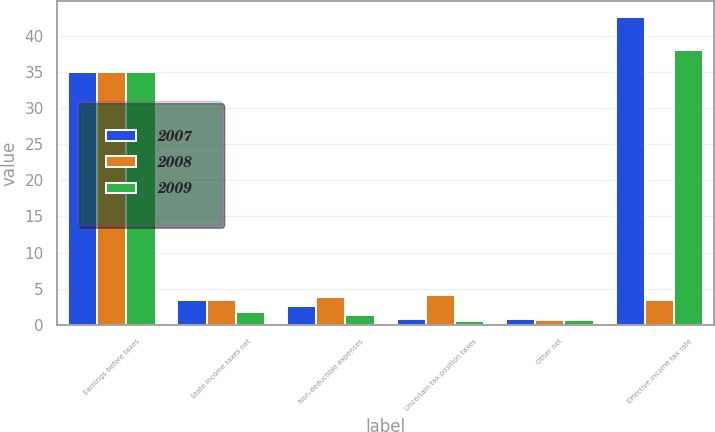<chart> <loc_0><loc_0><loc_500><loc_500><stacked_bar_chart><ecel><fcel>Earnings before taxes<fcel>State income taxes net<fcel>Non-deductible expenses<fcel>Uncertain tax position taxes<fcel>Other net<fcel>Effective income tax rate<nl><fcel>2007<fcel>35<fcel>3.4<fcel>2.6<fcel>0.8<fcel>0.8<fcel>42.6<nl><fcel>2008<fcel>35<fcel>3.5<fcel>3.9<fcel>4.2<fcel>0.7<fcel>3.4<nl><fcel>2009<fcel>35<fcel>1.8<fcel>1.4<fcel>0.5<fcel>0.7<fcel>38<nl></chart> 